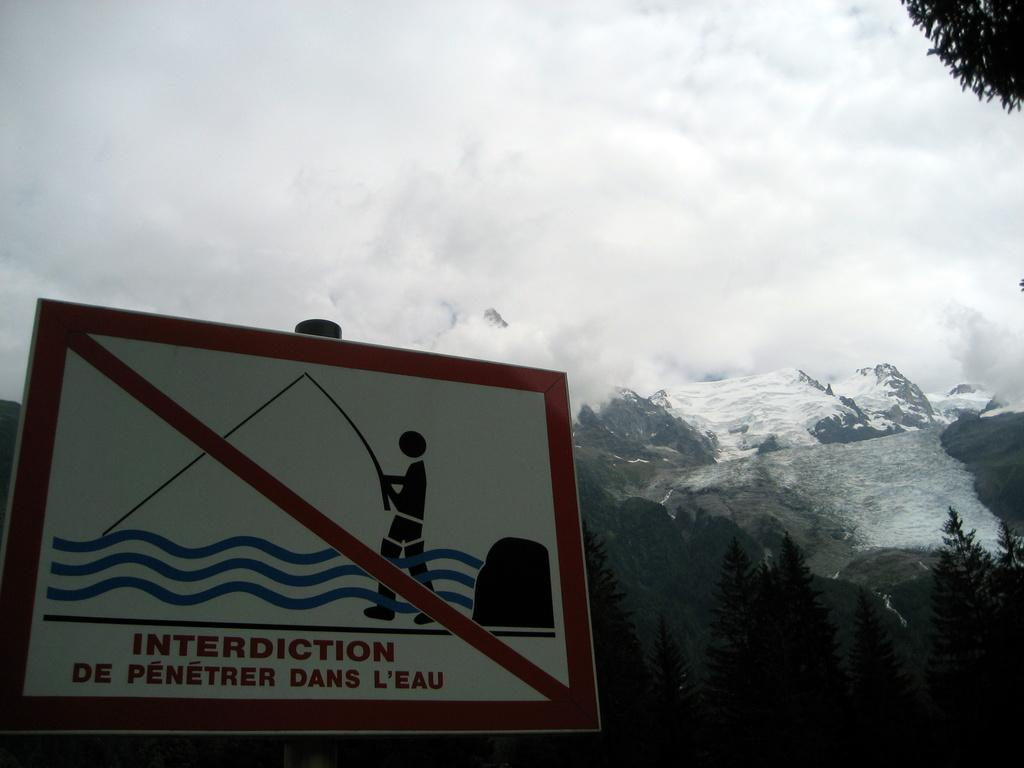Provide a one-sentence caption for the provided image. A sign with a man fishing with a red line through it and in a foreign language the sign says no fishing. 